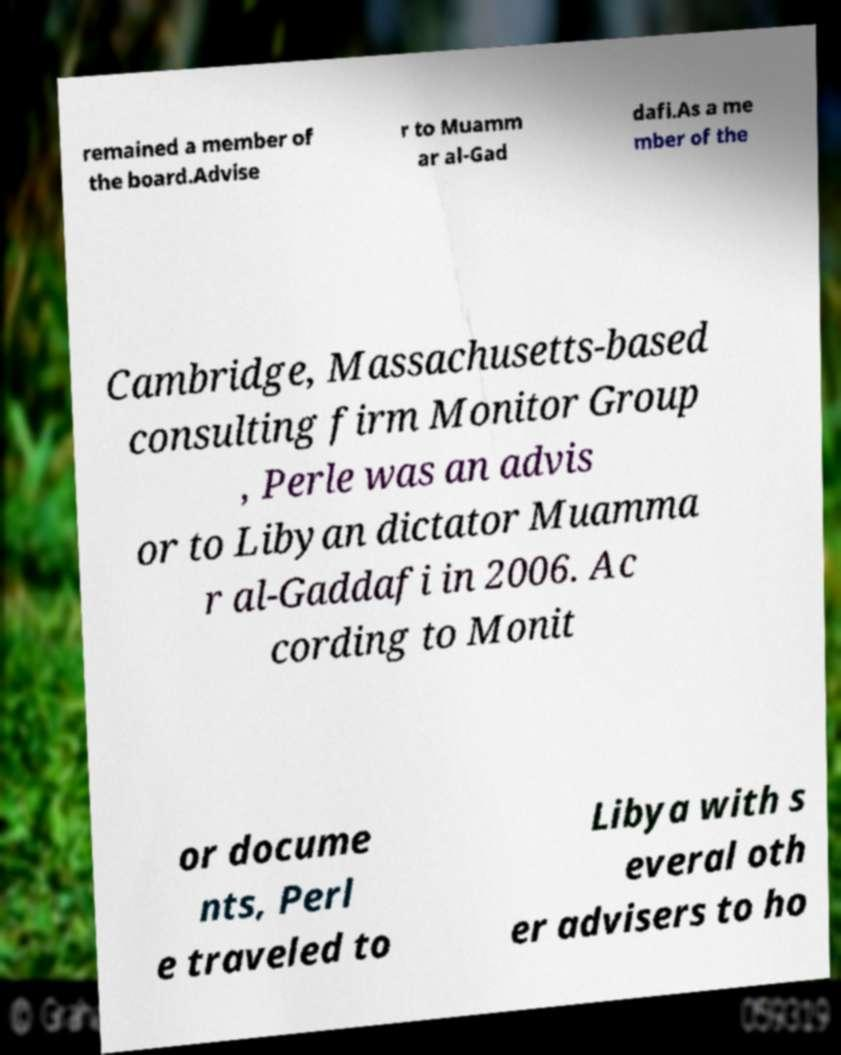Please read and relay the text visible in this image. What does it say? remained a member of the board.Advise r to Muamm ar al-Gad dafi.As a me mber of the Cambridge, Massachusetts-based consulting firm Monitor Group , Perle was an advis or to Libyan dictator Muamma r al-Gaddafi in 2006. Ac cording to Monit or docume nts, Perl e traveled to Libya with s everal oth er advisers to ho 